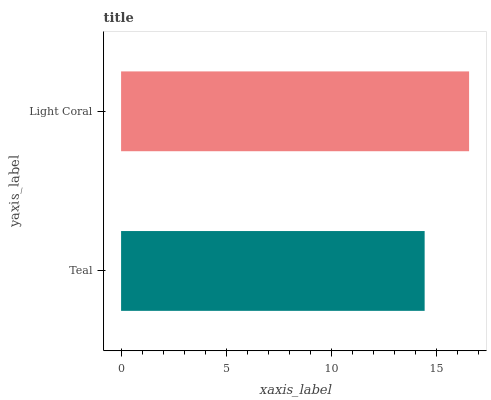Is Teal the minimum?
Answer yes or no. Yes. Is Light Coral the maximum?
Answer yes or no. Yes. Is Light Coral the minimum?
Answer yes or no. No. Is Light Coral greater than Teal?
Answer yes or no. Yes. Is Teal less than Light Coral?
Answer yes or no. Yes. Is Teal greater than Light Coral?
Answer yes or no. No. Is Light Coral less than Teal?
Answer yes or no. No. Is Light Coral the high median?
Answer yes or no. Yes. Is Teal the low median?
Answer yes or no. Yes. Is Teal the high median?
Answer yes or no. No. Is Light Coral the low median?
Answer yes or no. No. 